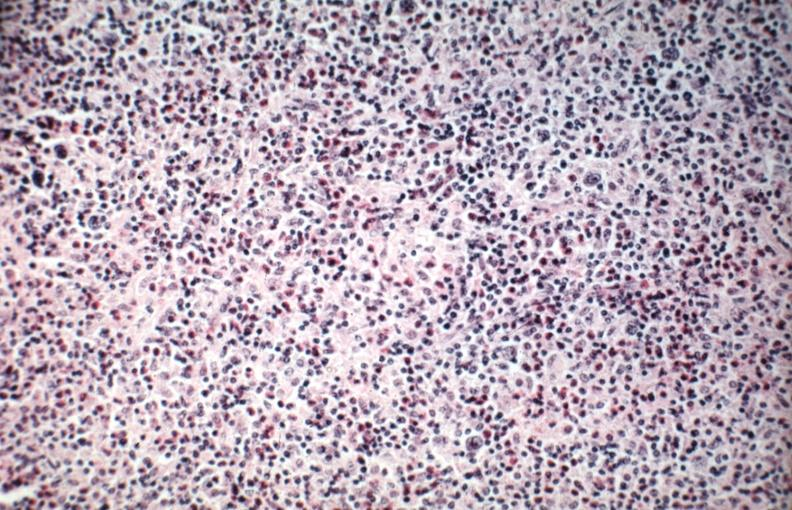s hodgkins disease present?
Answer the question using a single word or phrase. Yes 